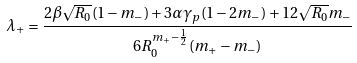Convert formula to latex. <formula><loc_0><loc_0><loc_500><loc_500>\lambda _ { + } = \frac { 2 \beta \sqrt { R _ { 0 } } ( 1 - m _ { - } ) + 3 \alpha \gamma _ { p } ( 1 - 2 m _ { - } ) + 1 2 \sqrt { R _ { 0 } } m _ { - } } { 6 R _ { 0 } ^ { m _ { + } - \frac { 1 } { 2 } } ( m _ { + } - m _ { - } ) }</formula> 